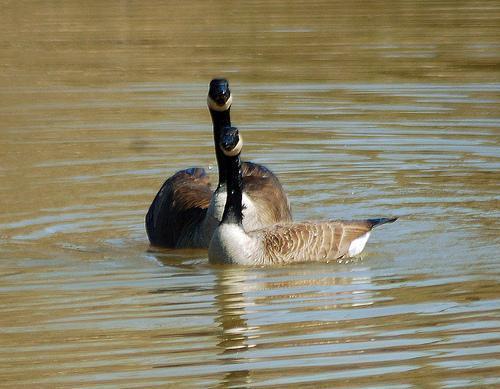How many animals are there?
Give a very brief answer. 2. 